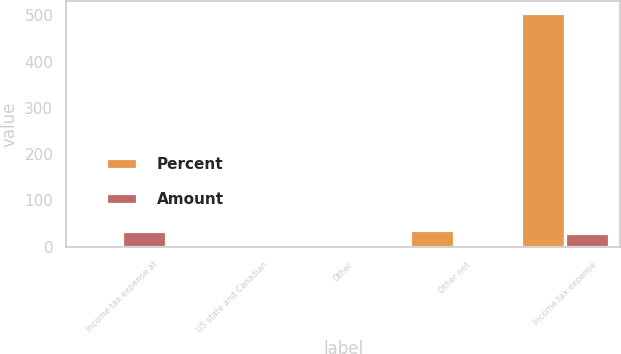Convert chart. <chart><loc_0><loc_0><loc_500><loc_500><stacked_bar_chart><ecel><fcel>Income tax expense at<fcel>US state and Canadian<fcel>Other<fcel>Other net<fcel>Income tax expense<nl><fcel>Percent<fcel>5<fcel>5<fcel>3<fcel>37<fcel>505<nl><fcel>Amount<fcel>35<fcel>0.3<fcel>0.2<fcel>2.1<fcel>29.2<nl></chart> 